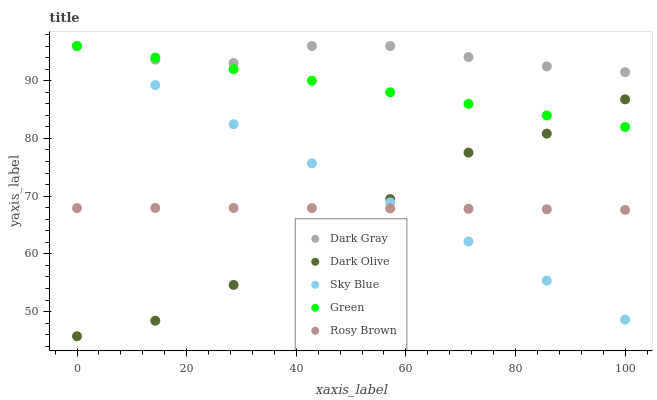Does Dark Olive have the minimum area under the curve?
Answer yes or no. Yes. Does Dark Gray have the maximum area under the curve?
Answer yes or no. Yes. Does Sky Blue have the minimum area under the curve?
Answer yes or no. No. Does Sky Blue have the maximum area under the curve?
Answer yes or no. No. Is Green the smoothest?
Answer yes or no. Yes. Is Dark Olive the roughest?
Answer yes or no. Yes. Is Sky Blue the smoothest?
Answer yes or no. No. Is Sky Blue the roughest?
Answer yes or no. No. Does Dark Olive have the lowest value?
Answer yes or no. Yes. Does Sky Blue have the lowest value?
Answer yes or no. No. Does Green have the highest value?
Answer yes or no. Yes. Does Rosy Brown have the highest value?
Answer yes or no. No. Is Dark Olive less than Dark Gray?
Answer yes or no. Yes. Is Dark Gray greater than Rosy Brown?
Answer yes or no. Yes. Does Sky Blue intersect Green?
Answer yes or no. Yes. Is Sky Blue less than Green?
Answer yes or no. No. Is Sky Blue greater than Green?
Answer yes or no. No. Does Dark Olive intersect Dark Gray?
Answer yes or no. No. 